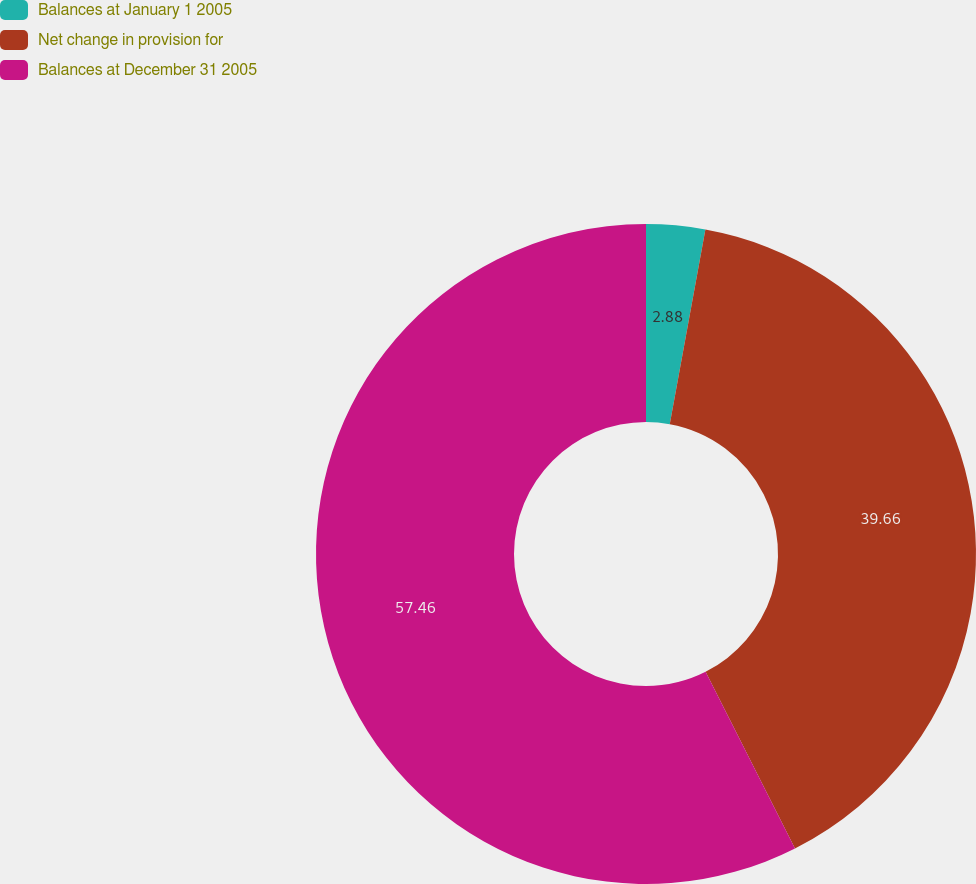Convert chart. <chart><loc_0><loc_0><loc_500><loc_500><pie_chart><fcel>Balances at January 1 2005<fcel>Net change in provision for<fcel>Balances at December 31 2005<nl><fcel>2.88%<fcel>39.66%<fcel>57.45%<nl></chart> 